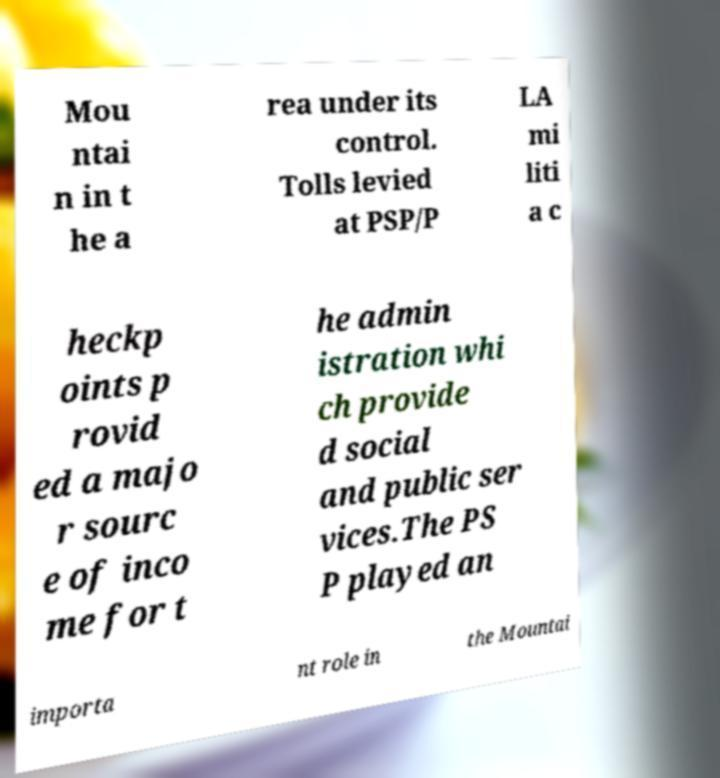What messages or text are displayed in this image? I need them in a readable, typed format. Mou ntai n in t he a rea under its control. Tolls levied at PSP/P LA mi liti a c heckp oints p rovid ed a majo r sourc e of inco me for t he admin istration whi ch provide d social and public ser vices.The PS P played an importa nt role in the Mountai 